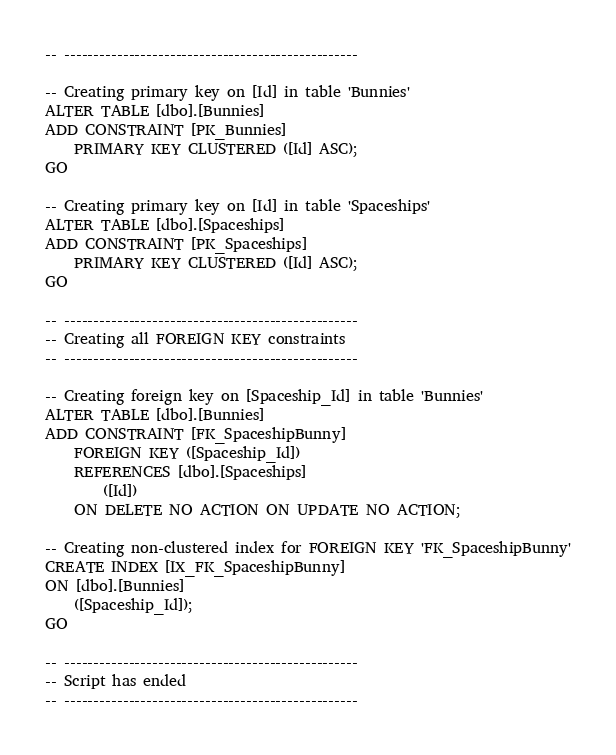Convert code to text. <code><loc_0><loc_0><loc_500><loc_500><_SQL_>-- --------------------------------------------------

-- Creating primary key on [Id] in table 'Bunnies'
ALTER TABLE [dbo].[Bunnies]
ADD CONSTRAINT [PK_Bunnies]
    PRIMARY KEY CLUSTERED ([Id] ASC);
GO

-- Creating primary key on [Id] in table 'Spaceships'
ALTER TABLE [dbo].[Spaceships]
ADD CONSTRAINT [PK_Spaceships]
    PRIMARY KEY CLUSTERED ([Id] ASC);
GO

-- --------------------------------------------------
-- Creating all FOREIGN KEY constraints
-- --------------------------------------------------

-- Creating foreign key on [Spaceship_Id] in table 'Bunnies'
ALTER TABLE [dbo].[Bunnies]
ADD CONSTRAINT [FK_SpaceshipBunny]
    FOREIGN KEY ([Spaceship_Id])
    REFERENCES [dbo].[Spaceships]
        ([Id])
    ON DELETE NO ACTION ON UPDATE NO ACTION;

-- Creating non-clustered index for FOREIGN KEY 'FK_SpaceshipBunny'
CREATE INDEX [IX_FK_SpaceshipBunny]
ON [dbo].[Bunnies]
    ([Spaceship_Id]);
GO

-- --------------------------------------------------
-- Script has ended
-- --------------------------------------------------</code> 